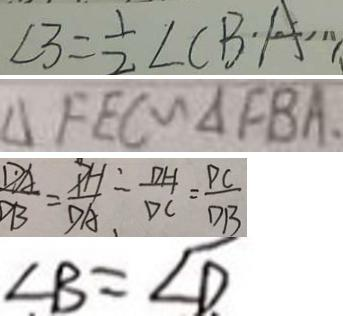Convert formula to latex. <formula><loc_0><loc_0><loc_500><loc_500>\angle 3 = \frac { 1 } { 2 } \angle C B A 
 \Delta F E C \sim \Delta F B A . 
 \frac { D A } { D B } = \frac { P H } { D A } _ { 、 } = \frac { D H } { D C } = \frac { P C } { D B } 
 \angle B = \angle D</formula> 